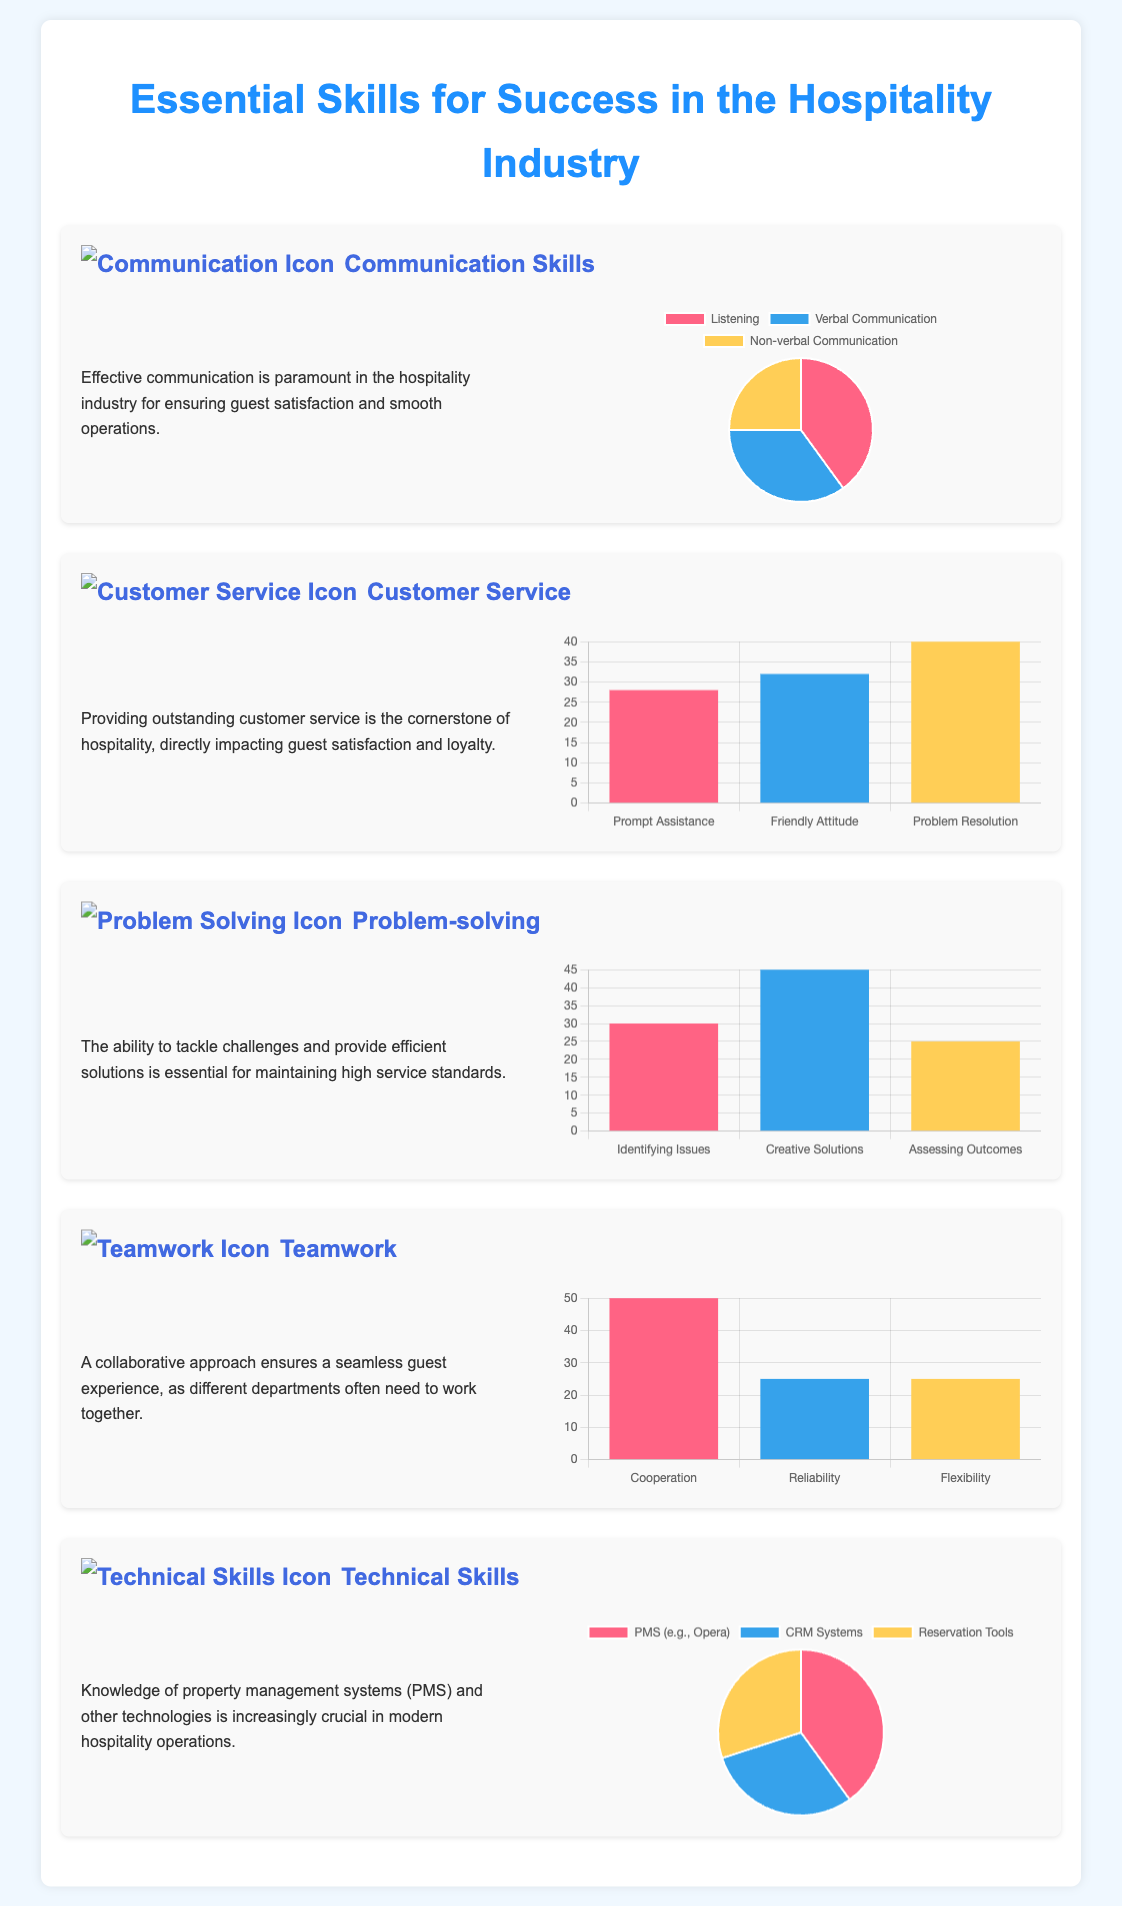What is the main title of the infographic? The title of the infographic is displayed prominently at the top of the document.
Answer: Essential Skills for Success in the Hospitality Industry What skill has the highest percentage in the communication chart? The communication chart indicates the skill with the highest percentage based on the pie chart visualization.
Answer: Listening What is the value representing 'Problem Resolution' in the customer service chart? The customer service chart shows several values, with 'Problem Resolution' having a specific numerical value indicated in the bar chart.
Answer: 40 Which skill shows the highest value in the problem-solving chart? The problem-solving chart lists various skills, and the highest value indicates which skill is deemed most critical.
Answer: Creative Solutions How many components are evaluated in the teamwork chart? The teamwork chart consists of several components represented in the bar chart, indicating the number of skills being assessed.
Answer: 3 What percentage is attributed to 'PMS (e.g., Opera)' in the technical skills chart? The technical skills chart features different skills with percentages, where 'PMS (e.g., Opera)' has a specific percentage recorded.
Answer: 40 What color is used for the 'Non-verbal Communication' slice in the communication chart? The communication pie chart utilizes specific colors to represent each segment, including Non-verbal Communication.
Answer: Light blue Which section describes the importance of working with different departments? This section details the importance of teamwork in creating a seamless guest experience.
Answer: Teamwork What type of chart displays the values for customer service? The specific chart type used for presenting customer service values is indicated in the document.
Answer: Bar chart 